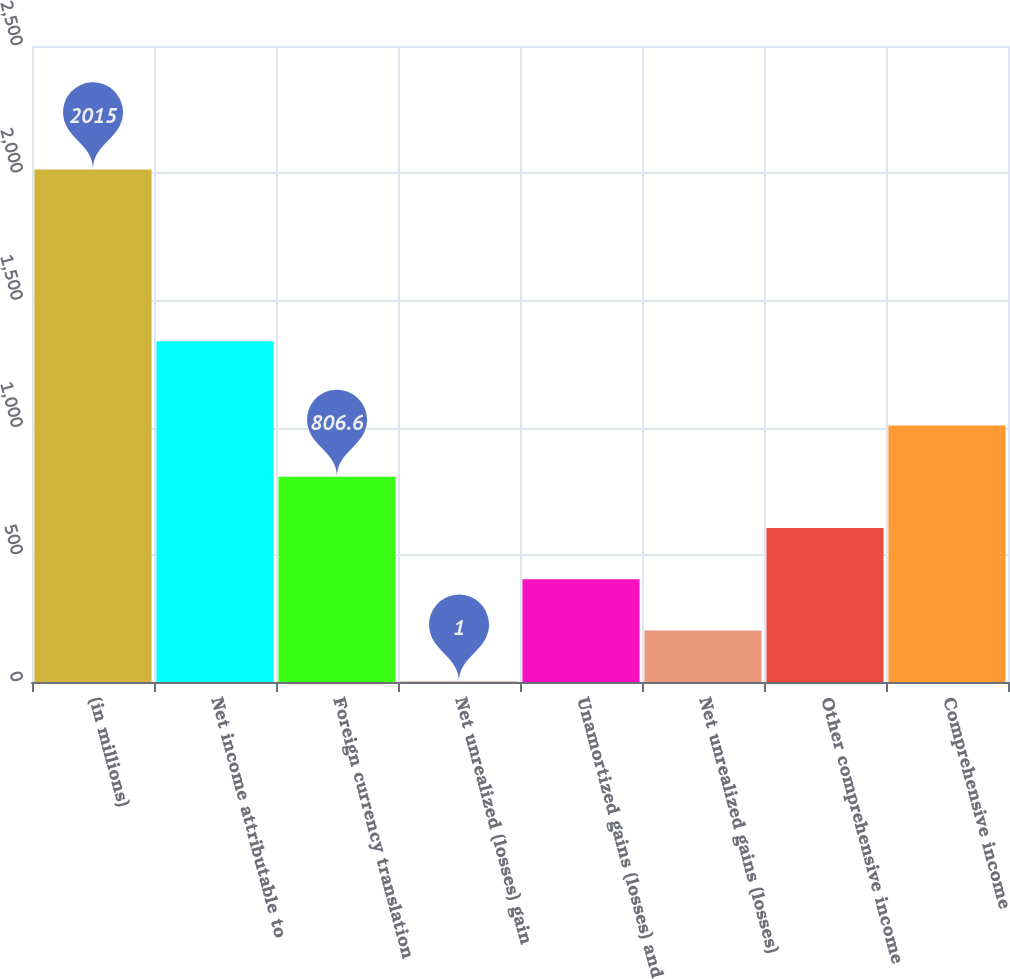<chart> <loc_0><loc_0><loc_500><loc_500><bar_chart><fcel>(in millions)<fcel>Net income attributable to<fcel>Foreign currency translation<fcel>Net unrealized (losses) gain<fcel>Unamortized gains (losses) and<fcel>Net unrealized gains (losses)<fcel>Other comprehensive income<fcel>Comprehensive income<nl><fcel>2015<fcel>1339<fcel>806.6<fcel>1<fcel>403.8<fcel>202.4<fcel>605.2<fcel>1008<nl></chart> 